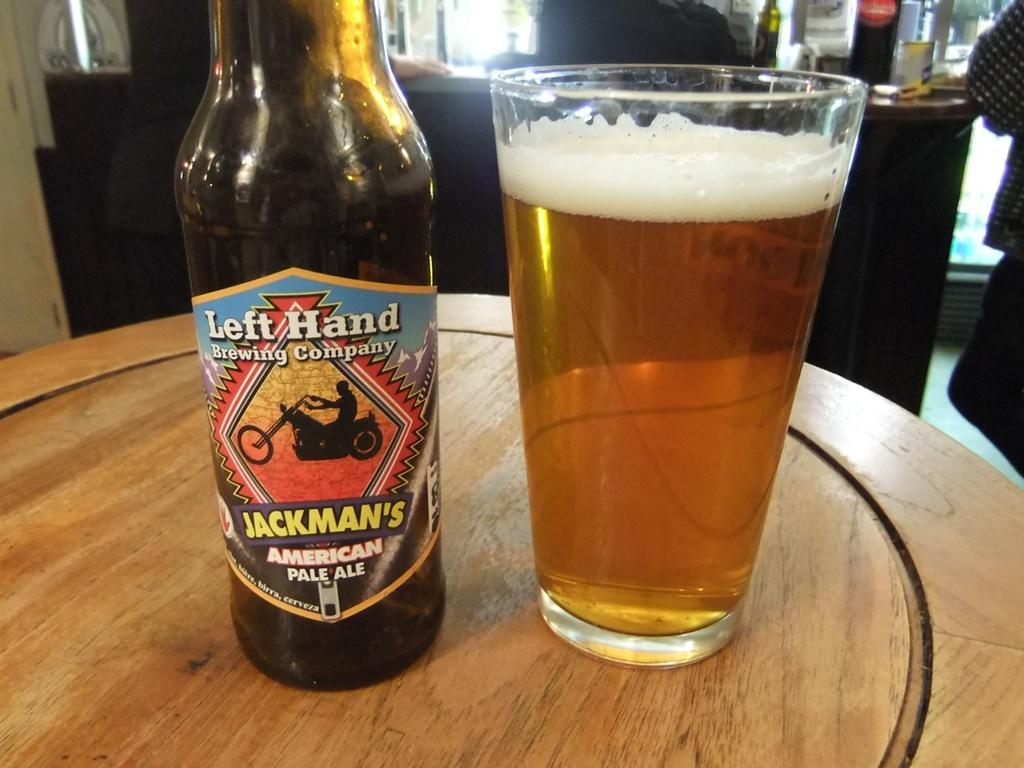<image>
Share a concise interpretation of the image provided. A glass of beer is sitting by a bottle of pale ale. 